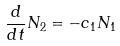<formula> <loc_0><loc_0><loc_500><loc_500>\frac { d } { d t } N _ { 2 } = - c _ { 1 } N _ { 1 }</formula> 